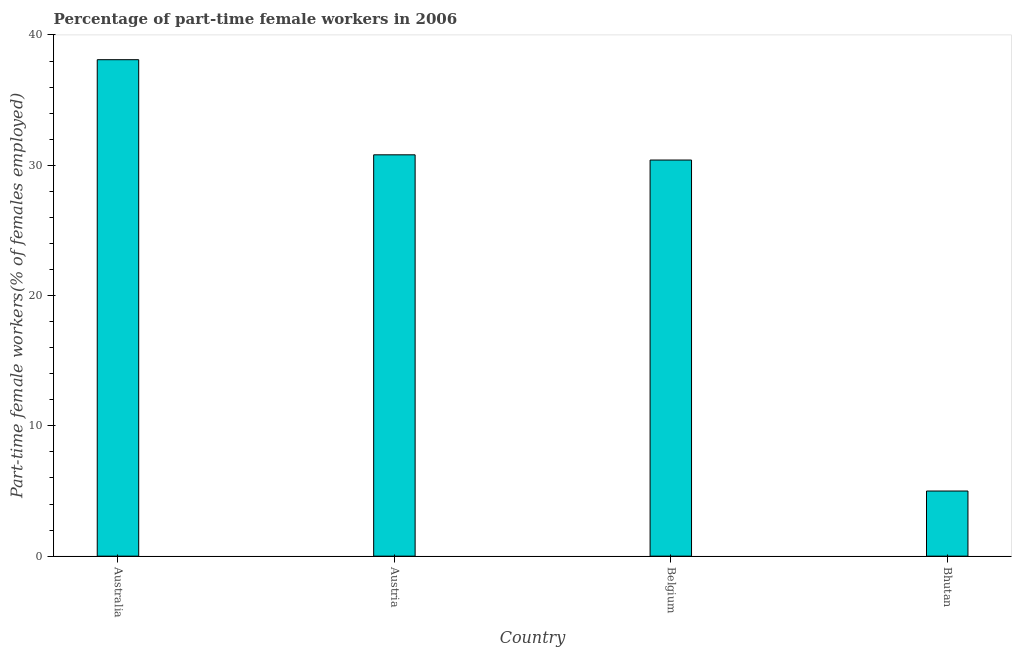Does the graph contain grids?
Offer a very short reply. No. What is the title of the graph?
Provide a short and direct response. Percentage of part-time female workers in 2006. What is the label or title of the X-axis?
Ensure brevity in your answer.  Country. What is the label or title of the Y-axis?
Offer a terse response. Part-time female workers(% of females employed). What is the percentage of part-time female workers in Bhutan?
Keep it short and to the point. 5. Across all countries, what is the maximum percentage of part-time female workers?
Offer a very short reply. 38.1. Across all countries, what is the minimum percentage of part-time female workers?
Provide a succinct answer. 5. In which country was the percentage of part-time female workers minimum?
Offer a very short reply. Bhutan. What is the sum of the percentage of part-time female workers?
Ensure brevity in your answer.  104.3. What is the difference between the percentage of part-time female workers in Australia and Bhutan?
Make the answer very short. 33.1. What is the average percentage of part-time female workers per country?
Offer a very short reply. 26.07. What is the median percentage of part-time female workers?
Your answer should be compact. 30.6. In how many countries, is the percentage of part-time female workers greater than 14 %?
Your answer should be compact. 3. What is the difference between the highest and the second highest percentage of part-time female workers?
Offer a very short reply. 7.3. What is the difference between the highest and the lowest percentage of part-time female workers?
Ensure brevity in your answer.  33.1. How many bars are there?
Keep it short and to the point. 4. Are all the bars in the graph horizontal?
Offer a terse response. No. How many countries are there in the graph?
Ensure brevity in your answer.  4. What is the Part-time female workers(% of females employed) in Australia?
Make the answer very short. 38.1. What is the Part-time female workers(% of females employed) in Austria?
Offer a terse response. 30.8. What is the Part-time female workers(% of females employed) in Belgium?
Provide a short and direct response. 30.4. What is the difference between the Part-time female workers(% of females employed) in Australia and Austria?
Make the answer very short. 7.3. What is the difference between the Part-time female workers(% of females employed) in Australia and Belgium?
Offer a terse response. 7.7. What is the difference between the Part-time female workers(% of females employed) in Australia and Bhutan?
Provide a short and direct response. 33.1. What is the difference between the Part-time female workers(% of females employed) in Austria and Belgium?
Offer a very short reply. 0.4. What is the difference between the Part-time female workers(% of females employed) in Austria and Bhutan?
Make the answer very short. 25.8. What is the difference between the Part-time female workers(% of females employed) in Belgium and Bhutan?
Ensure brevity in your answer.  25.4. What is the ratio of the Part-time female workers(% of females employed) in Australia to that in Austria?
Make the answer very short. 1.24. What is the ratio of the Part-time female workers(% of females employed) in Australia to that in Belgium?
Provide a short and direct response. 1.25. What is the ratio of the Part-time female workers(% of females employed) in Australia to that in Bhutan?
Ensure brevity in your answer.  7.62. What is the ratio of the Part-time female workers(% of females employed) in Austria to that in Bhutan?
Provide a succinct answer. 6.16. What is the ratio of the Part-time female workers(% of females employed) in Belgium to that in Bhutan?
Your answer should be compact. 6.08. 